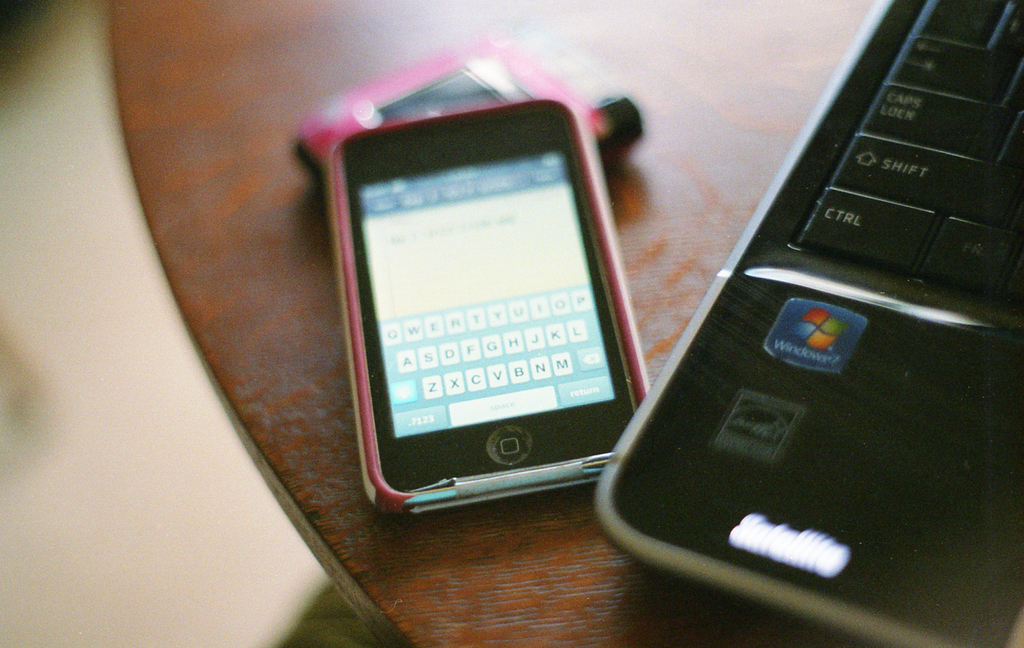Can you describe the aesthetic appeal of this image and what it might symbolize? This image exudes a retro technological charm, highlighting the transition period where mobile phones and personal computers were becoming essential daily tools. The juxtaposition of older technology with their distinct, tactile keys against a wood grain surface symbolizes a simpler time in tech, before the advent of touchscreen and ultra-modern designs. 